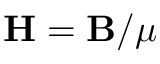<formula> <loc_0><loc_0><loc_500><loc_500>{ H } = { B } / \mu</formula> 